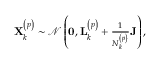Convert formula to latex. <formula><loc_0><loc_0><loc_500><loc_500>\begin{array} { r } { X _ { k } ^ { \left ( p \right ) } \sim \mathcal { N } \left ( 0 , L _ { k } ^ { \left ( p \right ) } + \frac { 1 } { N _ { k } ^ { \left ( p \right ) } } J \right ) , } \end{array}</formula> 